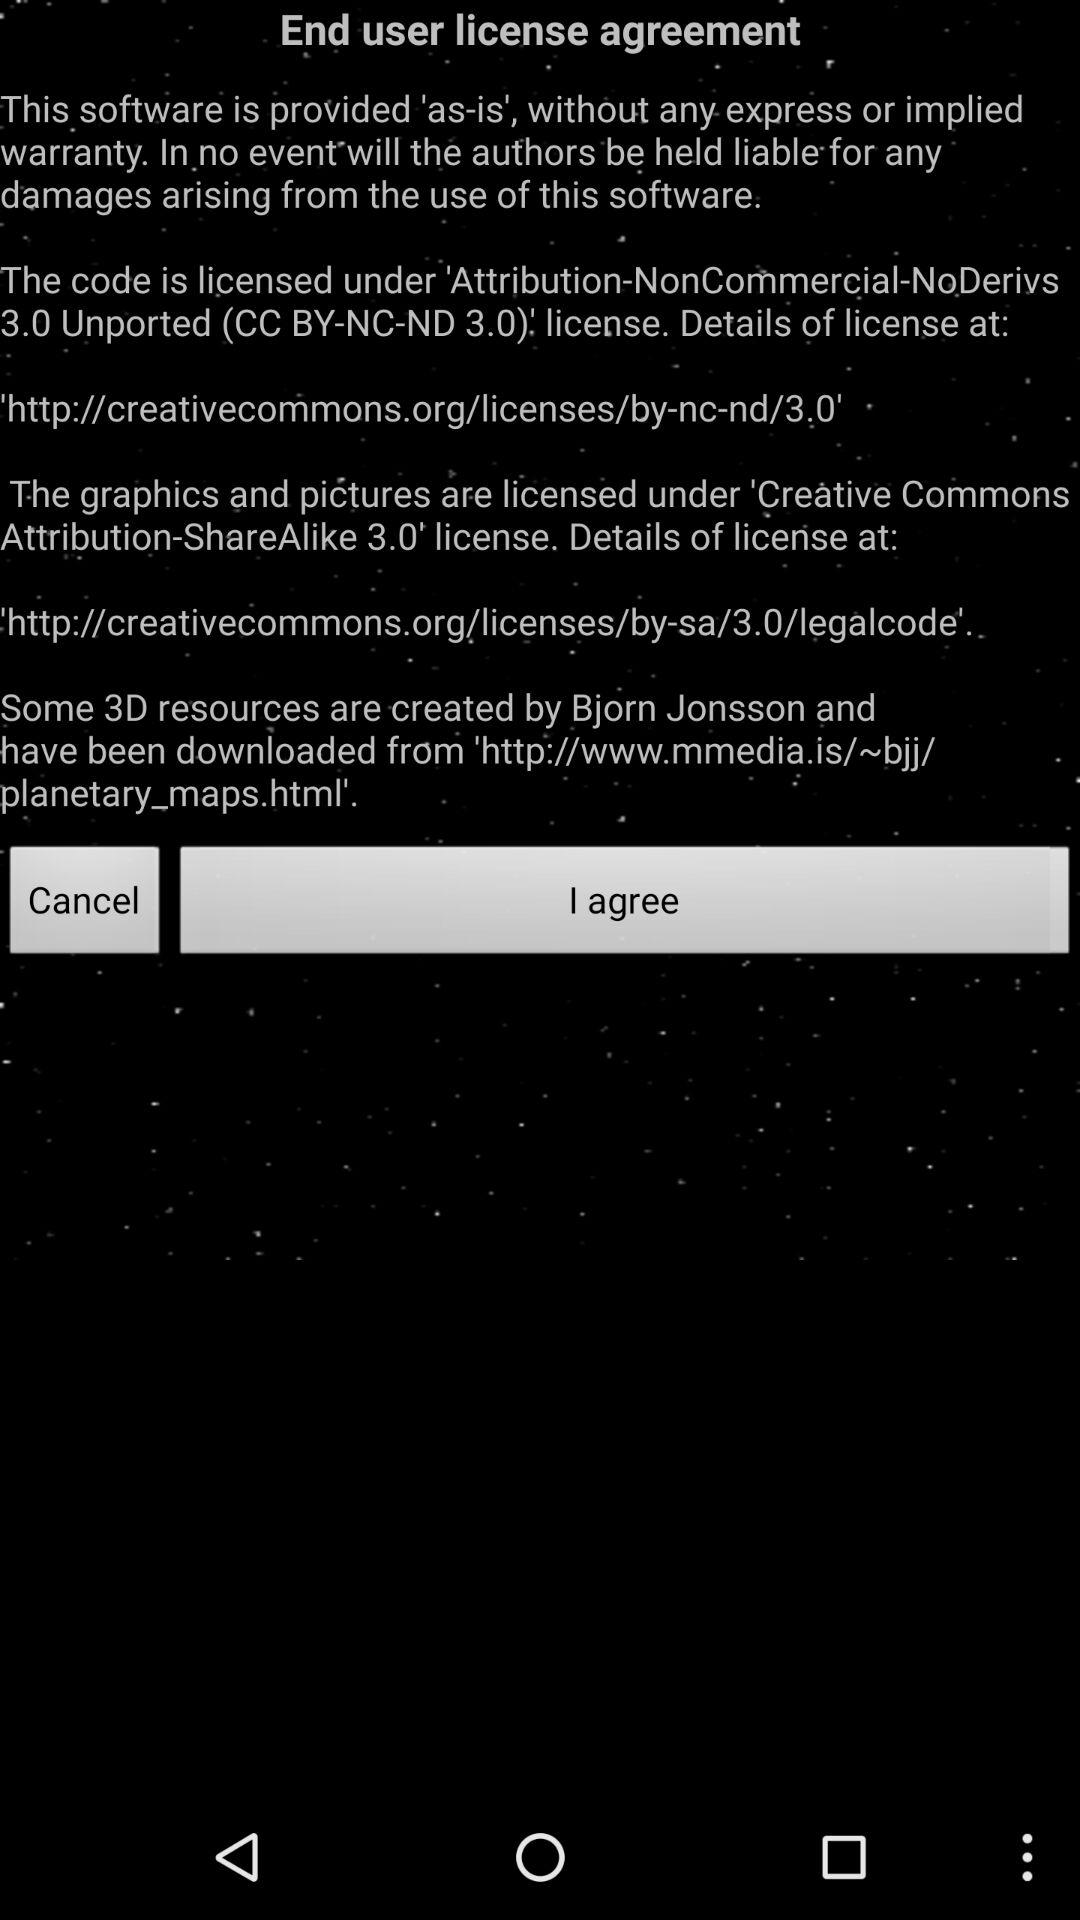Which button has to be clicked to agree to the license agreement? The button that has to be clicked to agree to the license agreement is "I agree". 